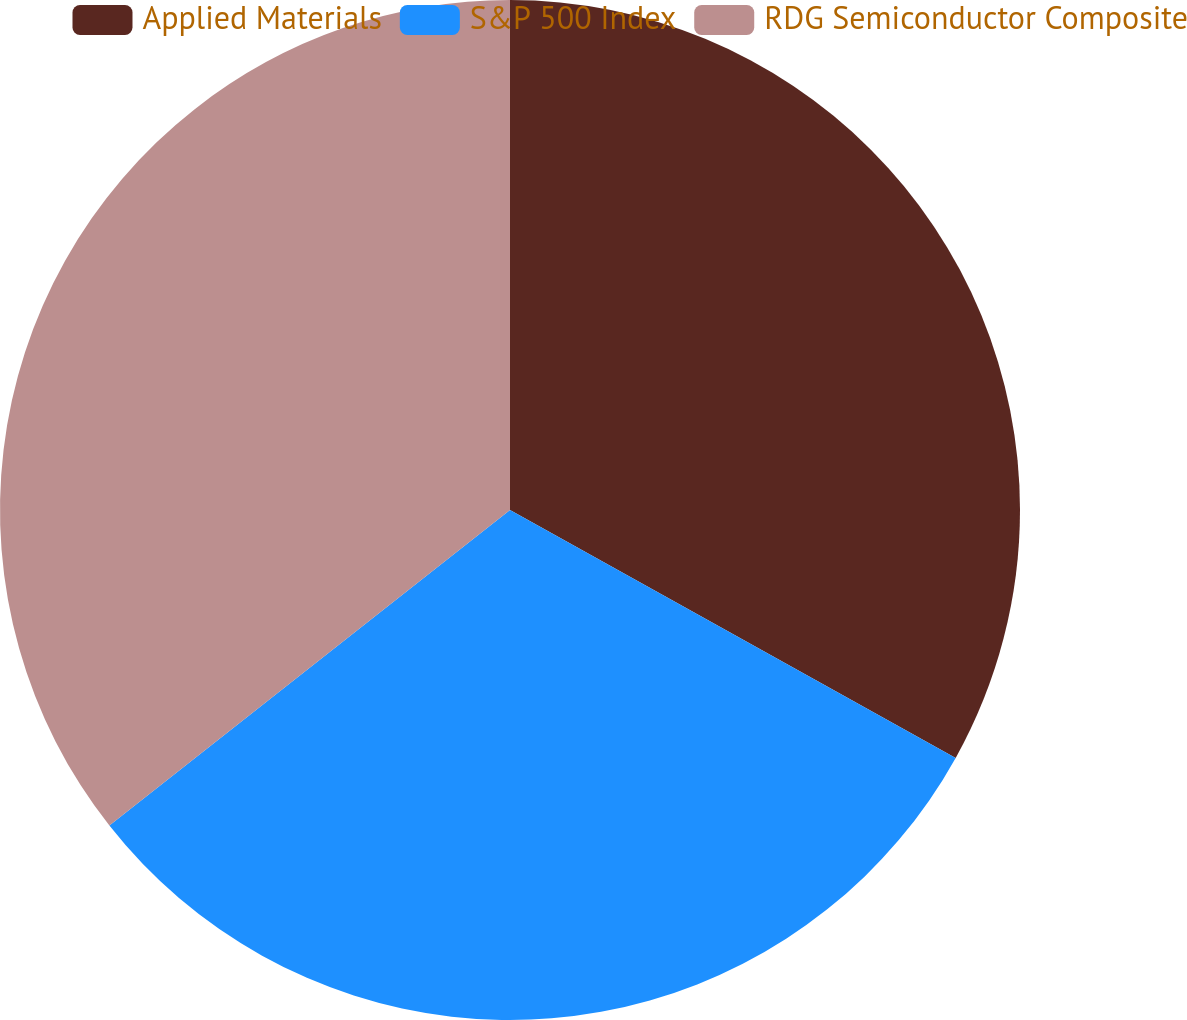Convert chart to OTSL. <chart><loc_0><loc_0><loc_500><loc_500><pie_chart><fcel>Applied Materials<fcel>S&P 500 Index<fcel>RDG Semiconductor Composite<nl><fcel>33.08%<fcel>31.3%<fcel>35.62%<nl></chart> 